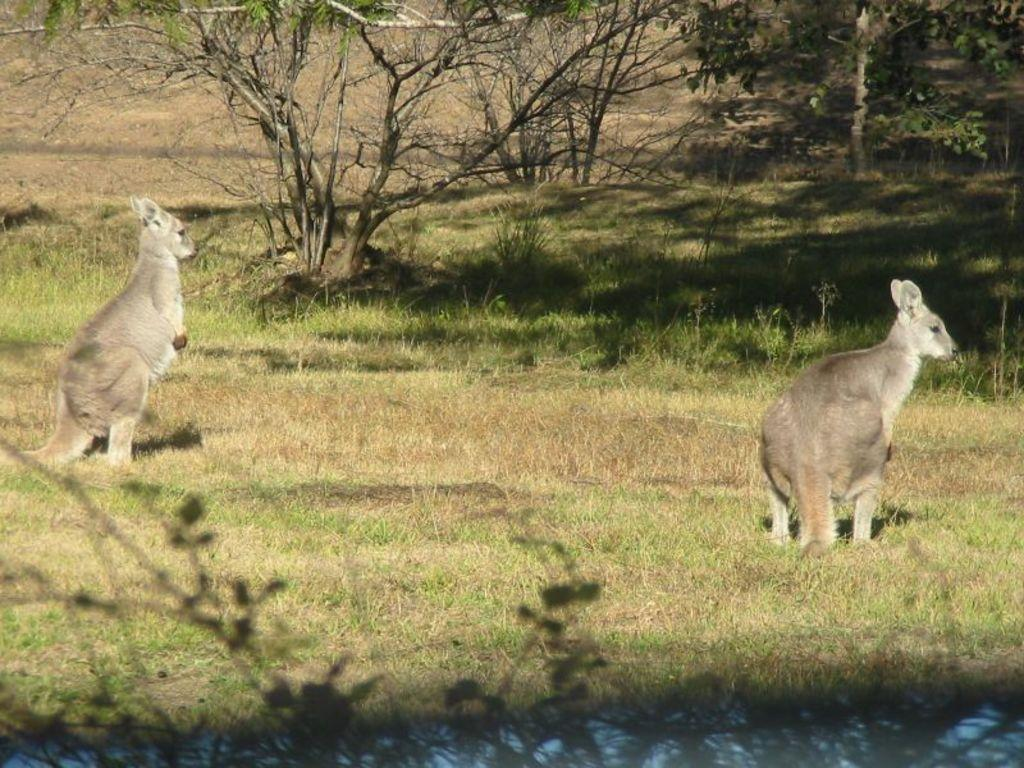What type of animals can be seen on the ground in the image? The specific type of animals is not mentioned, but there are animals on the ground in the image. What can be seen in the background of the image? There are trees visible in the background of the image. What color is the ball that is rolling on the side of the animals in the image? There is no ball present in the image, and the animals are on the ground, not the side. 